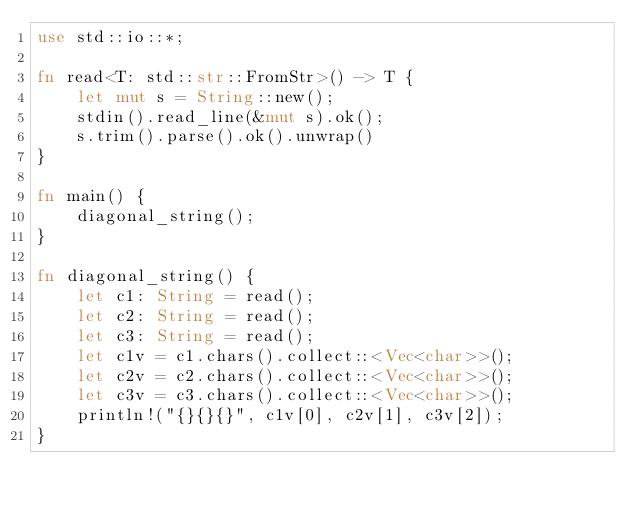<code> <loc_0><loc_0><loc_500><loc_500><_Rust_>use std::io::*;

fn read<T: std::str::FromStr>() -> T {
    let mut s = String::new();
    stdin().read_line(&mut s).ok();
    s.trim().parse().ok().unwrap()
}

fn main() {
    diagonal_string();
}

fn diagonal_string() {
    let c1: String = read();
    let c2: String = read();
    let c3: String = read();
    let c1v = c1.chars().collect::<Vec<char>>();
    let c2v = c2.chars().collect::<Vec<char>>();
    let c3v = c3.chars().collect::<Vec<char>>();
    println!("{}{}{}", c1v[0], c2v[1], c3v[2]);
}</code> 